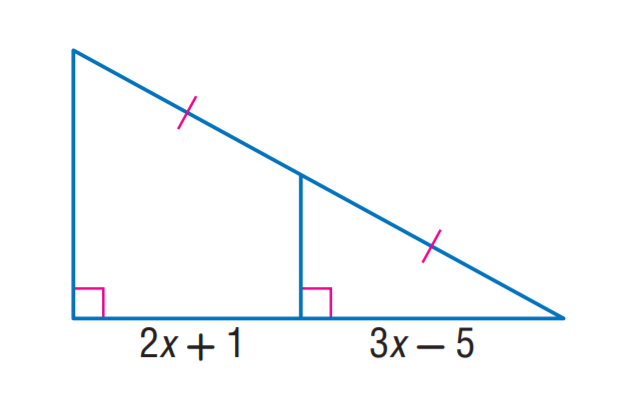Answer the mathemtical geometry problem and directly provide the correct option letter.
Question: Find x.
Choices: A: 2 B: 3 C: 5 D: 6 D 